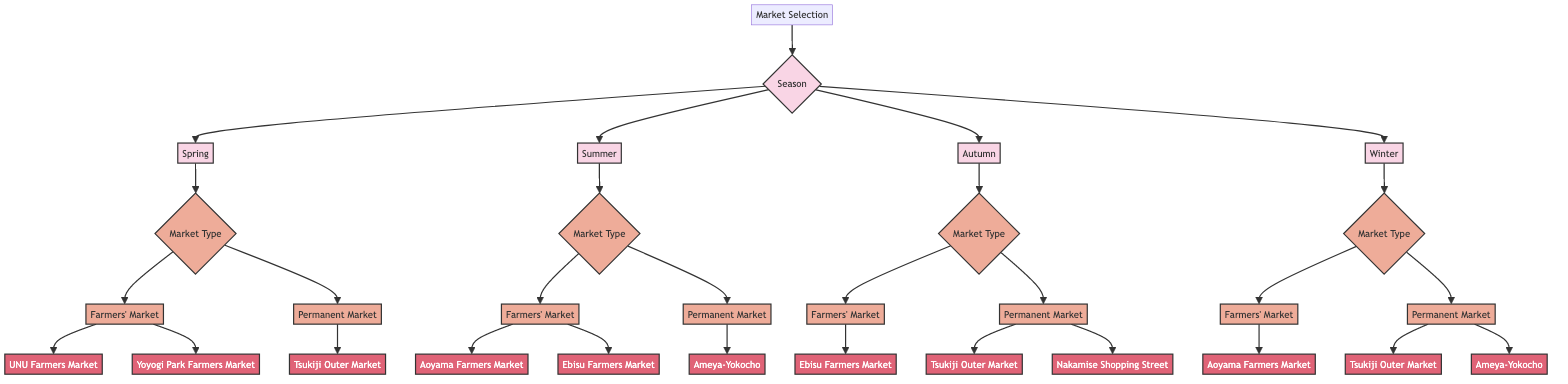What is the main focus of the diagram? The diagram focuses on selecting markets in Tokyo for seasonal produce shopping based on the season. This is indicated by the root node titled "Market Selection," which branches into seasons like Spring, Summer, Autumn, and Winter.
Answer: Market Selection How many seasons are represented in the diagram? The diagram includes four seasons: Spring, Summer, Autumn, and Winter. Each of these seasons is a direct child of the "Season" node, indicating their representation in the diagram.
Answer: Four Which market is recommended for Spring under Farmers' Market? The Farmers' Market in Spring consists of two recommendations: UNU Farmers Market and Yoyogi Park Farmers Market. According to the diagram, UNU Farmers Market is the first one listed under this category.
Answer: UNU Farmers Market What type of market is Tsukiji Outer Market? Tsukiji Outer Market is categorized as a Permanent Market in both Spring and Autumn sections of the diagram. The "Market Type" node for these seasons directly connects to the Tsukiji Outer Market recommendation.
Answer: Permanent Market In which season is Ebisu Farmers Market recommended? Ebisu Farmers Market is mentioned in both Summer and Autumn. However, we can reason through the diagram, where it is recommended under Farmers' Market for both seasons. Therefore, the answer takes into account that it fits two seasonal recommendations.
Answer: Summer and Autumn Which fruit is available at Aoyama Farmers Market in Winter? Aoyama Farmers Market is stated to be the best for root vegetables and citrus fruits in the Winter section. This is connected under the Farmers' Market for the Winter season.
Answer: Root vegetables and citrus fruits What is the second recommendation listed for Autumn under Permanent Market? In the Autumn section's Permanent Market category, Tsukiji Outer Market is listed first, followed by Nakamise Shopping Street as the second recommendation listed. This ordering is evident from the child nodes under the Autumn's Market Type.
Answer: Nakamise Shopping Street How many recommendations are there for Summer's Farmers' Market? The Summer's Farmers' Market level contains two recommendations: Aoyama Farmers Market and Ebisu Farmers Market. Each of them is listed under the Farmers' Market node designated for the Summer season.
Answer: Two Which market is best for winter seafood and is recommended for both Winter and Autumn? The Tsukiji Outer Market is recommended for winter seafood in Winter and also for spring seafood in Spring, indicated under their respective Market Type nodes for seafood.
Answer: Tsukiji Outer Market 